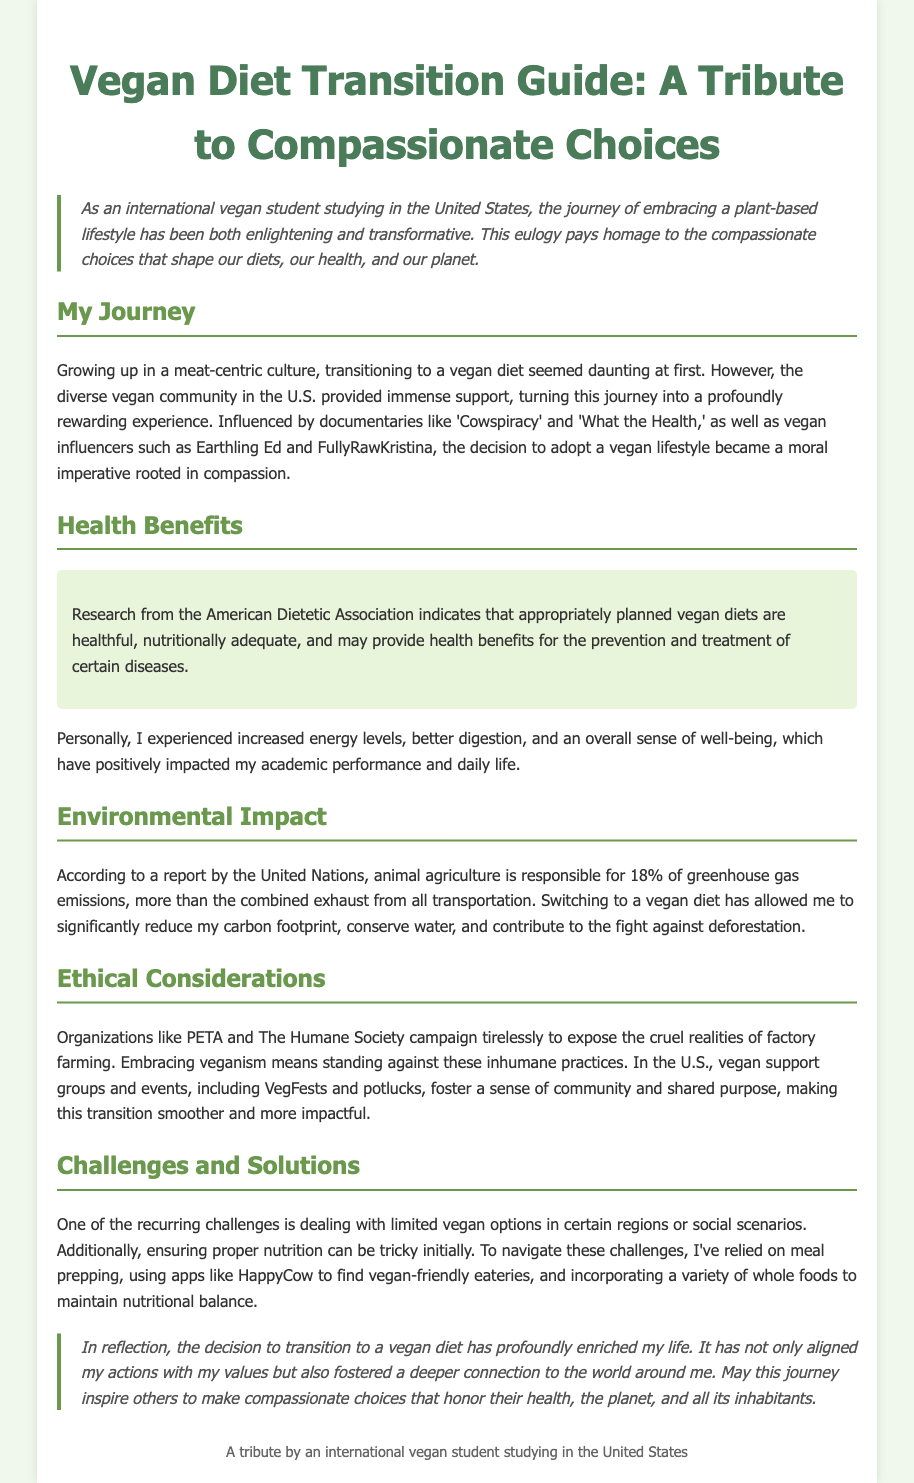What is the title of the document? The title can be found at the start of the document and is "Vegan Diet Transition Guide: A Tribute to Compassionate Choices."
Answer: Vegan Diet Transition Guide: A Tribute to Compassionate Choices What notable documentaries influenced the author's decision to adopt a vegan lifestyle? The author mentions two documentaries that had a significant impact: "Cowspiracy" and "What the Health."
Answer: Cowspiracy and What the Health What percentage of greenhouse gas emissions is attributed to animal agriculture according to the United Nations? The document states that animal agriculture is responsible for 18% of greenhouse gas emissions.
Answer: 18% What app does the author recommend for finding vegan-friendly eateries? The author mentions using the app "HappyCow" to locate vegan-friendly dining options.
Answer: HappyCow What are two benefits the author experienced after transitioning to a vegan diet? The author notes experiencing increased energy levels and better digestion as benefits of the vegan diet.
Answer: Increased energy levels; better digestion What motivates the author to embrace veganism? The author embraces veganism as a moral imperative rooted in compassion, reflecting their ethical beliefs against inhumane practices.
Answer: Compassion What community events does the author mention that help foster a sense of belonging during the transition? The author mentions "VegFests" and potlucks as community events that promote a shared sense of purpose.
Answer: VegFests and potlucks What are two common challenges faced during the transition to a vegan diet? The author highlights limited vegan options in different regions and ensuring proper nutrition as common challenges.
Answer: Limited vegan options; ensuring proper nutrition 